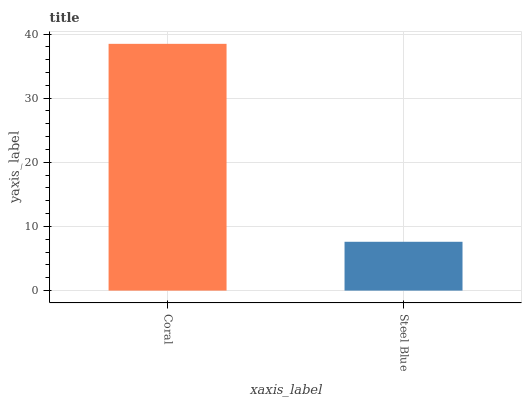Is Steel Blue the minimum?
Answer yes or no. Yes. Is Coral the maximum?
Answer yes or no. Yes. Is Steel Blue the maximum?
Answer yes or no. No. Is Coral greater than Steel Blue?
Answer yes or no. Yes. Is Steel Blue less than Coral?
Answer yes or no. Yes. Is Steel Blue greater than Coral?
Answer yes or no. No. Is Coral less than Steel Blue?
Answer yes or no. No. Is Coral the high median?
Answer yes or no. Yes. Is Steel Blue the low median?
Answer yes or no. Yes. Is Steel Blue the high median?
Answer yes or no. No. Is Coral the low median?
Answer yes or no. No. 